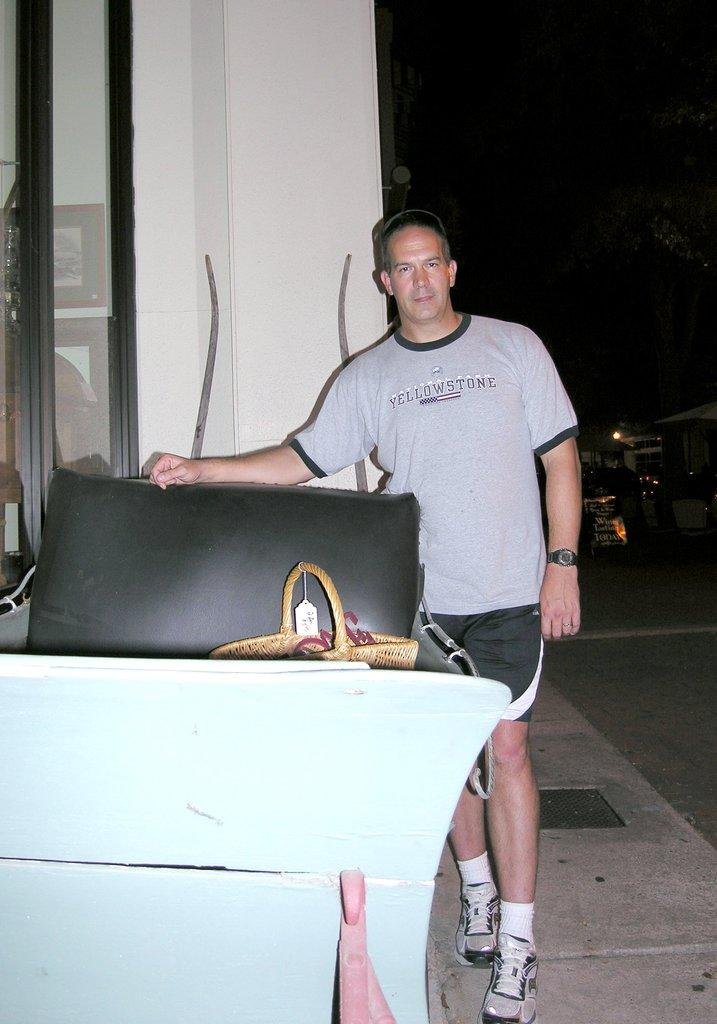What is the main subject of the image? There is a man standing in the middle of the image. What is the man wearing on his upper body? The man is wearing a t-shirt. What is the man wearing on his lower body? The man is wearing shorts. What accessory is the man wearing on his wrist? The man is wearing a watch. What type of footwear is the man wearing? The man is wearing shoes. What can be seen on the left side of the image? There is a glass window on the left side of the image. How does the man wash his hands in the image? There is no indication in the image that the man is washing his hands, so it cannot be determined from the picture. 